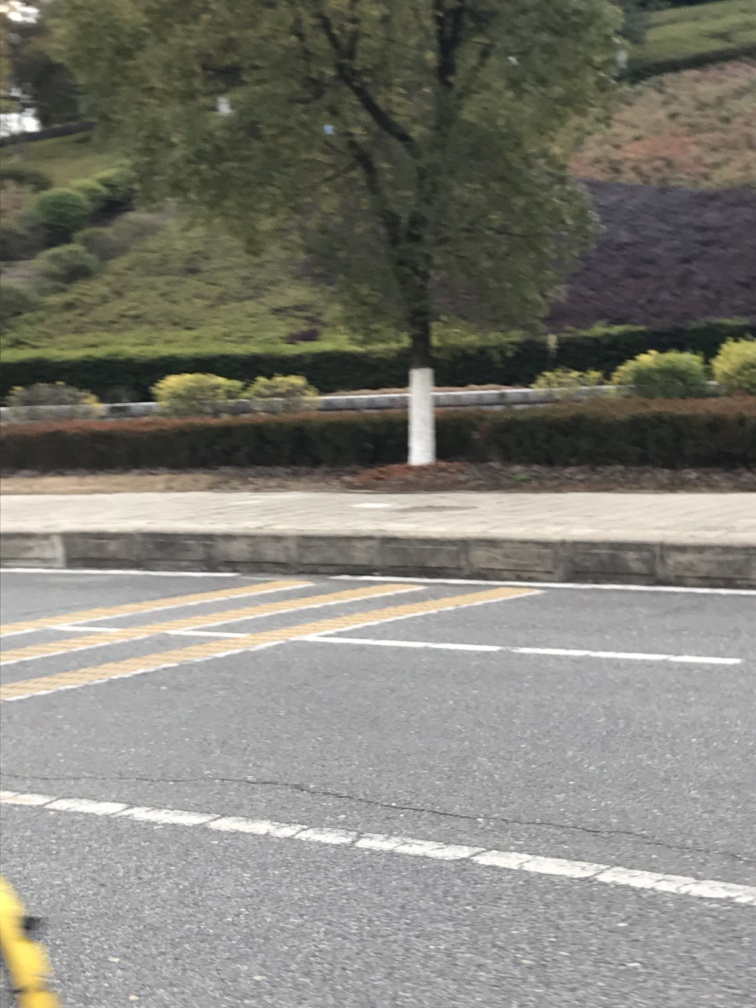Does the image have noticeable motion blur?
A. Yes
B. No
Answer with the option's letter from the given choices directly.
 A. 